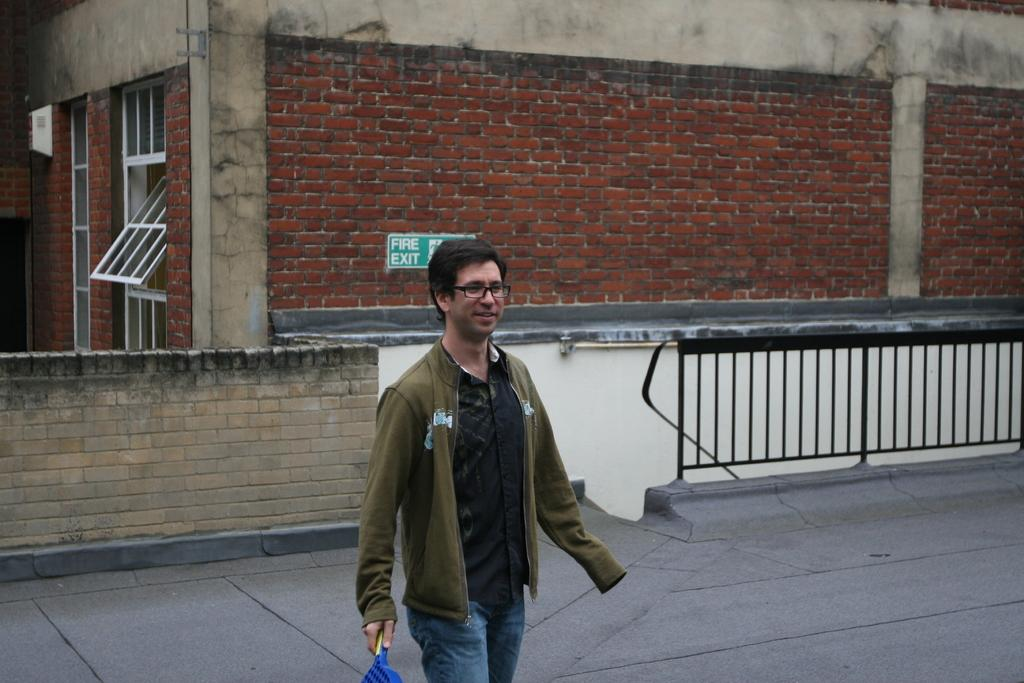What is the main subject in the foreground of the image? There is a man in the foreground of the image. What is the man wearing? The man is wearing a coat. What is the man holding in the image? The man is holding an object. What can be seen in the background of the image? There is a road, a wall, a railing, a building, and a sign board in the background of the image. What type of bottle can be seen on the man's coat in the image? There is no bottle visible on the man's coat in the image. What color is the paint on the sign board in the image? The image does not provide information about the color of the paint on the sign board. 